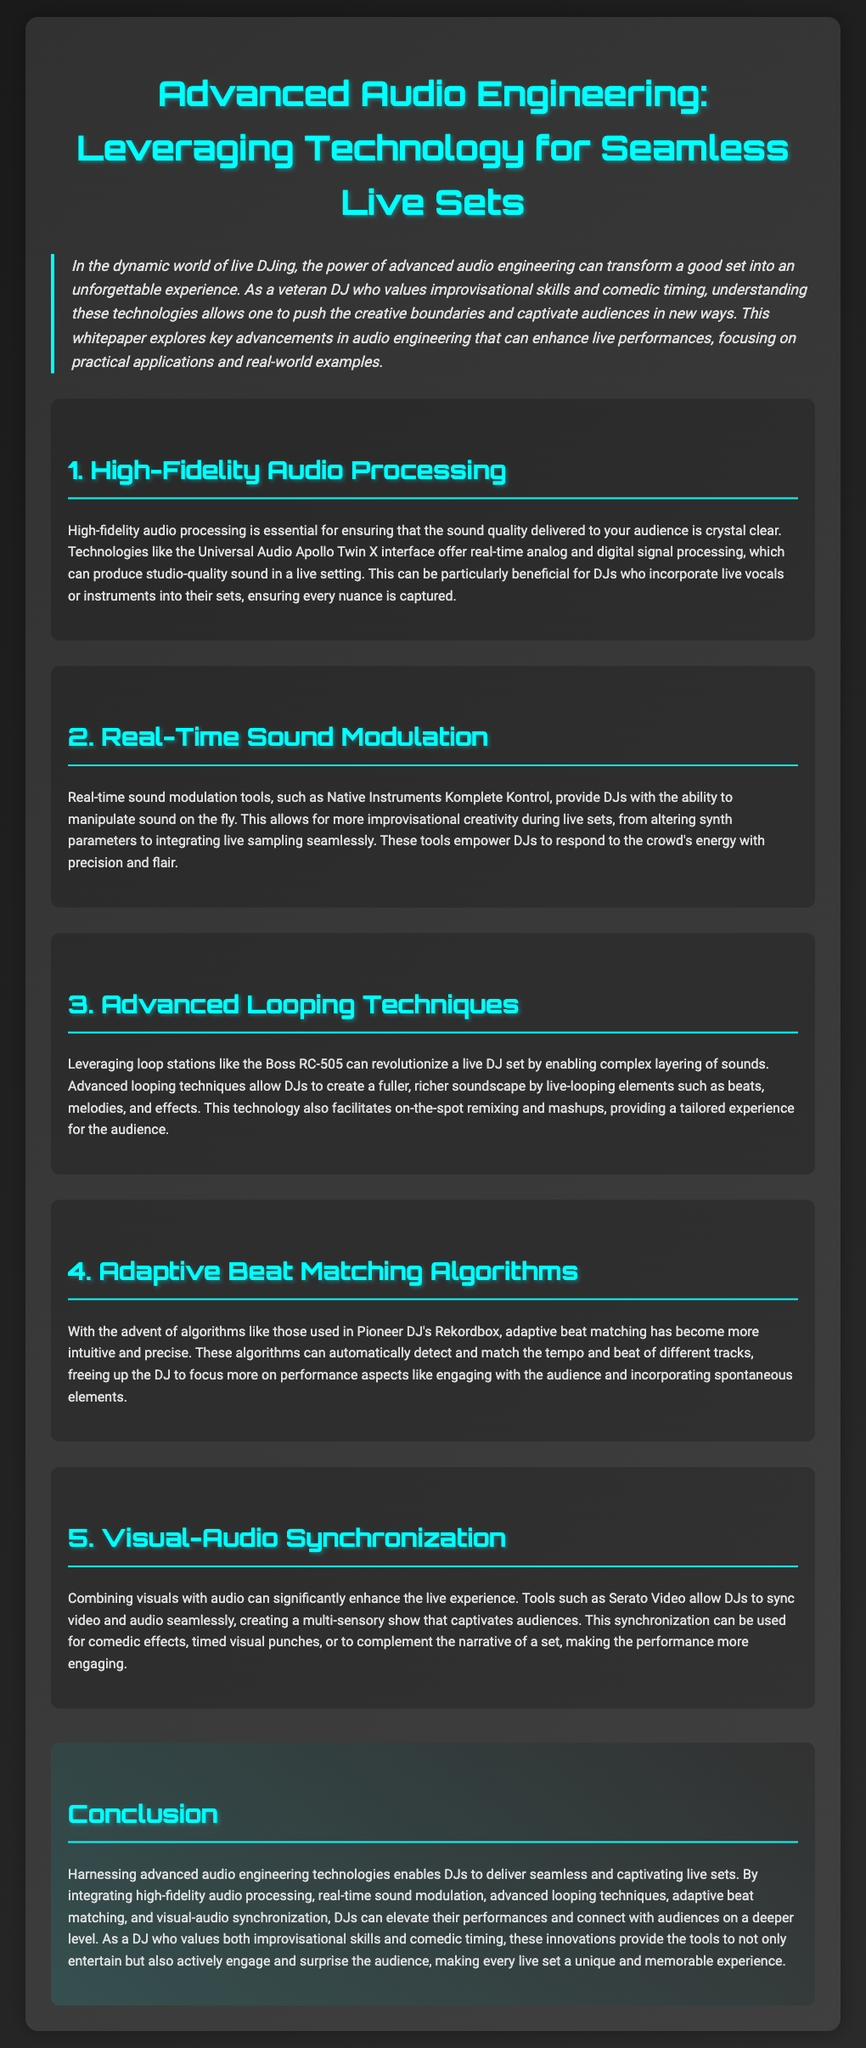What are high-fidelity audio processing technologies useful for? High-fidelity audio processing ensures that the sound quality delivered to your audience is crystal clear.
Answer: Sound quality Name a tool used for real-time sound modulation. The document mentions Native Instruments Komplete Kontrol as a tool for real-time sound modulation.
Answer: Native Instruments Komplete Kontrol What can advanced looping techniques create in a DJ set? Advanced looping techniques allow DJs to create a fuller, richer soundscape by live-looping elements.
Answer: Fuller soundscape What is an example of visual-audio synchronization software? The document states that Serato Video is a tool that allows for visual-audio synchronization.
Answer: Serato Video What does adaptive beat matching free up for the DJ? Adaptive beat matching algorithms free up the DJ to focus more on performance aspects.
Answer: Performance aspects Which audio engineering technology impacts audience engagement the most? Combining visuals with audio significantly enhances the live experience and engagement with audiences.
Answer: Visuals with audio In what context can comedic effects be used according to the document? Comedic effects can be used in visual-audio synchronization to complement the narrative of a set.
Answer: Visual-audio synchronization How can DJs use advanced technologies according to the conclusion? DJs can leverage advanced audio engineering technologies to deliver seamless and captivating live sets.
Answer: Seamless sets 